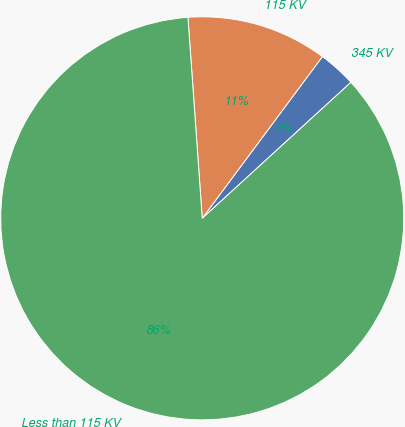Convert chart. <chart><loc_0><loc_0><loc_500><loc_500><pie_chart><fcel>345 KV<fcel>115 KV<fcel>Less than 115 KV<nl><fcel>3.04%<fcel>11.3%<fcel>85.67%<nl></chart> 